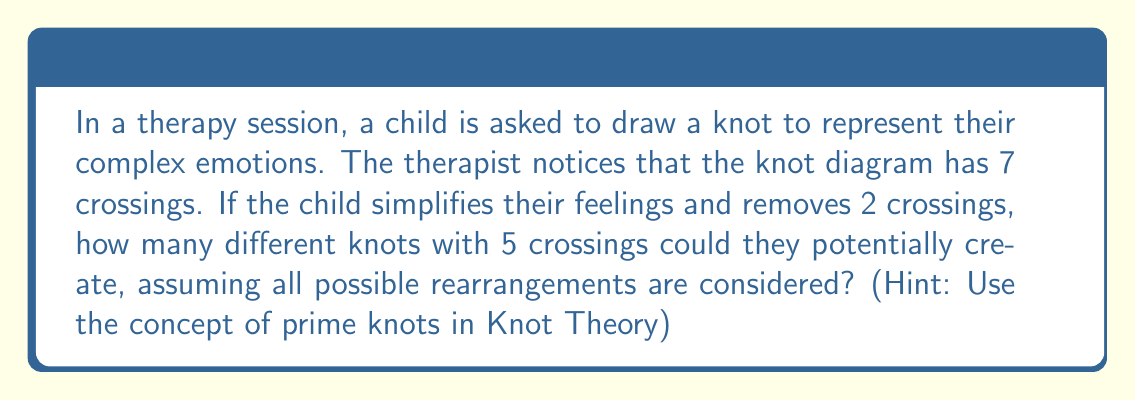Help me with this question. To solve this problem, we need to consider the concept of prime knots in Knot Theory. Let's break it down step-by-step:

1) First, recall that prime knots are knots that cannot be decomposed into simpler knots. They are the building blocks of more complex knots.

2) In Knot Theory, it's known that there are exactly 2 distinct prime knots with 5 crossings: the 5₁ knot (three-twist knot) and the 5₂ knot (cinquefoil knot).

3) However, the question asks for all possible knots with 5 crossings, not just prime knots. We need to consider composite knots as well.

4) Composite knots with 5 crossings can be formed by combining prime knots with fewer crossings. The possibilities are:
   - 3₁ # 2₁ (trefoil knot connected with a simple loop)
   - 2₁ # 2₁ # 1₀ (two simple loops connected with an unknot)

5) Therefore, the total number of distinct knots with 5 crossings is:
   $$2 \text{ (prime knots)} + 2 \text{ (composite knots)} = 4$$

6) This number symbolizes the different ways a child might simplify or rearrange their complex emotions, represented by the original 7-crossing knot.
Answer: 4 